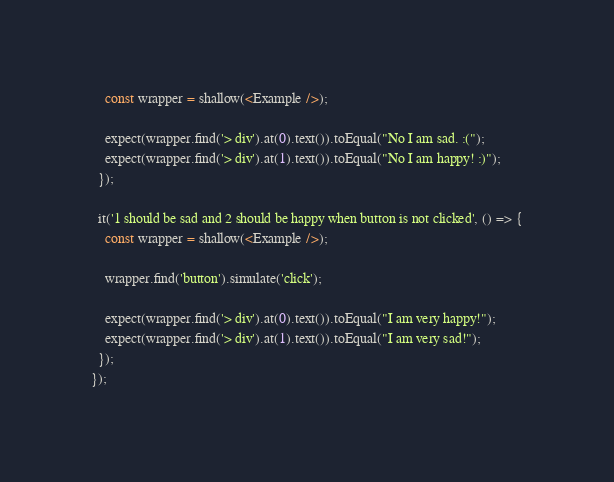Convert code to text. <code><loc_0><loc_0><loc_500><loc_500><_JavaScript_>    const wrapper = shallow(<Example />);

    expect(wrapper.find('> div').at(0).text()).toEqual("No I am sad. :(");
    expect(wrapper.find('> div').at(1).text()).toEqual("No I am happy! :)");
  });

  it('1 should be sad and 2 should be happy when button is not clicked', () => {
    const wrapper = shallow(<Example />);

    wrapper.find('button').simulate('click');

    expect(wrapper.find('> div').at(0).text()).toEqual("I am very happy!");
    expect(wrapper.find('> div').at(1).text()).toEqual("I am very sad!");
  });
});
</code> 